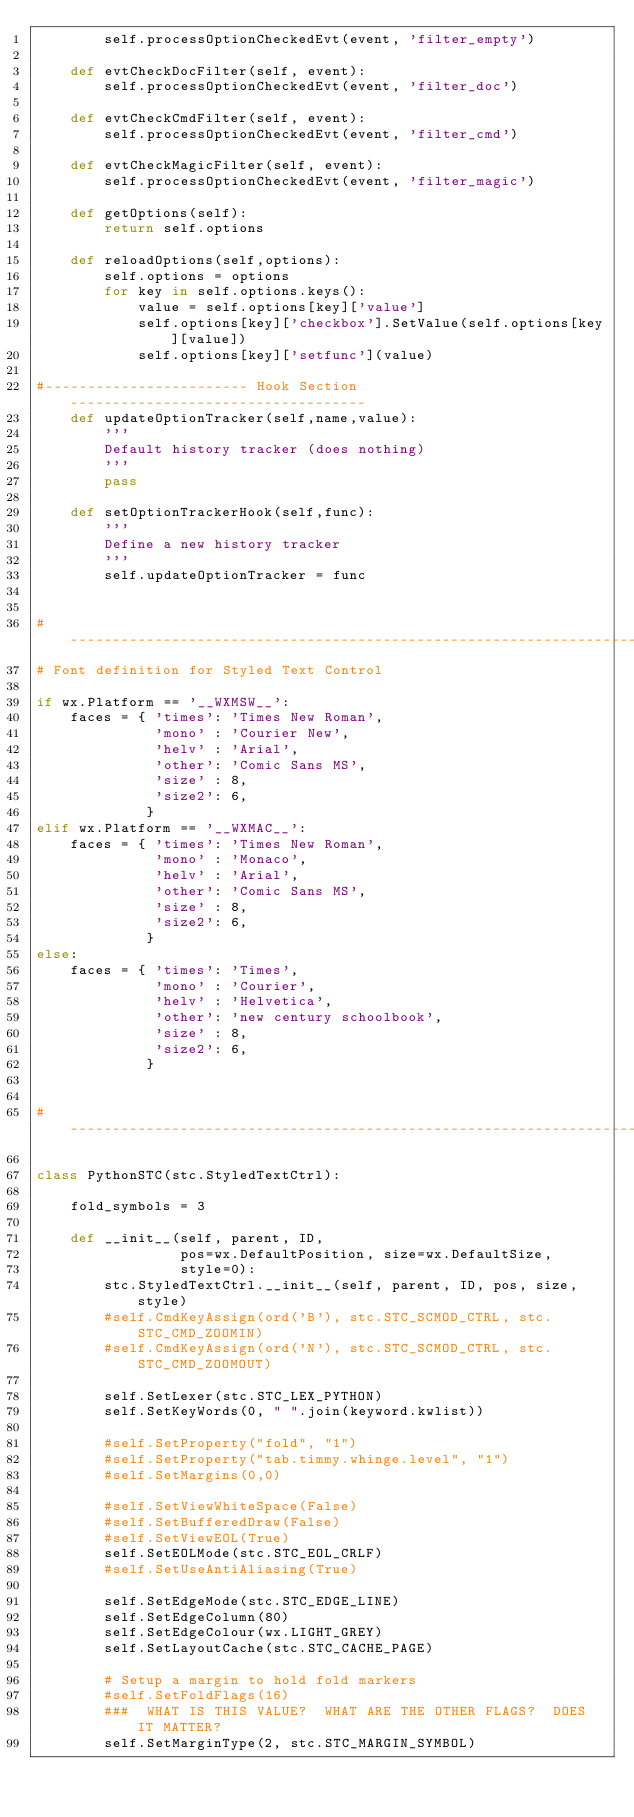Convert code to text. <code><loc_0><loc_0><loc_500><loc_500><_Python_>        self.processOptionCheckedEvt(event, 'filter_empty')
        
    def evtCheckDocFilter(self, event):
        self.processOptionCheckedEvt(event, 'filter_doc')

    def evtCheckCmdFilter(self, event):
        self.processOptionCheckedEvt(event, 'filter_cmd')

    def evtCheckMagicFilter(self, event):
        self.processOptionCheckedEvt(event, 'filter_magic')
        
    def getOptions(self):
        return self.options
    
    def reloadOptions(self,options):
        self.options = options
        for key in self.options.keys():
            value = self.options[key]['value']
            self.options[key]['checkbox'].SetValue(self.options[key][value])
            self.options[key]['setfunc'](value)

#------------------------ Hook Section -----------------------------------
    def updateOptionTracker(self,name,value):
        '''
        Default history tracker (does nothing)
        '''
        pass
    
    def setOptionTrackerHook(self,func):
        '''
        Define a new history tracker
        '''
        self.updateOptionTracker = func

            
#----------------------------------------------------------------------
# Font definition for Styled Text Control

if wx.Platform == '__WXMSW__':
    faces = { 'times': 'Times New Roman',
              'mono' : 'Courier New',
              'helv' : 'Arial',
              'other': 'Comic Sans MS',
              'size' : 8,
              'size2': 6,
             }
elif wx.Platform == '__WXMAC__':
    faces = { 'times': 'Times New Roman',
              'mono' : 'Monaco',
              'helv' : 'Arial',
              'other': 'Comic Sans MS',
              'size' : 8,
              'size2': 6,
             }
else:
    faces = { 'times': 'Times',
              'mono' : 'Courier',
              'helv' : 'Helvetica',
              'other': 'new century schoolbook',
              'size' : 8,
              'size2': 6,
             }


#----------------------------------------------------------------------

class PythonSTC(stc.StyledTextCtrl):

    fold_symbols = 3
    
    def __init__(self, parent, ID,
                 pos=wx.DefaultPosition, size=wx.DefaultSize,
                 style=0):
        stc.StyledTextCtrl.__init__(self, parent, ID, pos, size, style)
        #self.CmdKeyAssign(ord('B'), stc.STC_SCMOD_CTRL, stc.STC_CMD_ZOOMIN)
        #self.CmdKeyAssign(ord('N'), stc.STC_SCMOD_CTRL, stc.STC_CMD_ZOOMOUT)

        self.SetLexer(stc.STC_LEX_PYTHON)
        self.SetKeyWords(0, " ".join(keyword.kwlist))

        #self.SetProperty("fold", "1")
        #self.SetProperty("tab.timmy.whinge.level", "1")
        #self.SetMargins(0,0)

        #self.SetViewWhiteSpace(False)
        #self.SetBufferedDraw(False)
        #self.SetViewEOL(True)
        self.SetEOLMode(stc.STC_EOL_CRLF)
        #self.SetUseAntiAliasing(True)
        
        self.SetEdgeMode(stc.STC_EDGE_LINE)
        self.SetEdgeColumn(80)
        self.SetEdgeColour(wx.LIGHT_GREY)
        self.SetLayoutCache(stc.STC_CACHE_PAGE)

        # Setup a margin to hold fold markers
        #self.SetFoldFlags(16)  
        ###  WHAT IS THIS VALUE?  WHAT ARE THE OTHER FLAGS?  DOES IT MATTER?
        self.SetMarginType(2, stc.STC_MARGIN_SYMBOL)</code> 